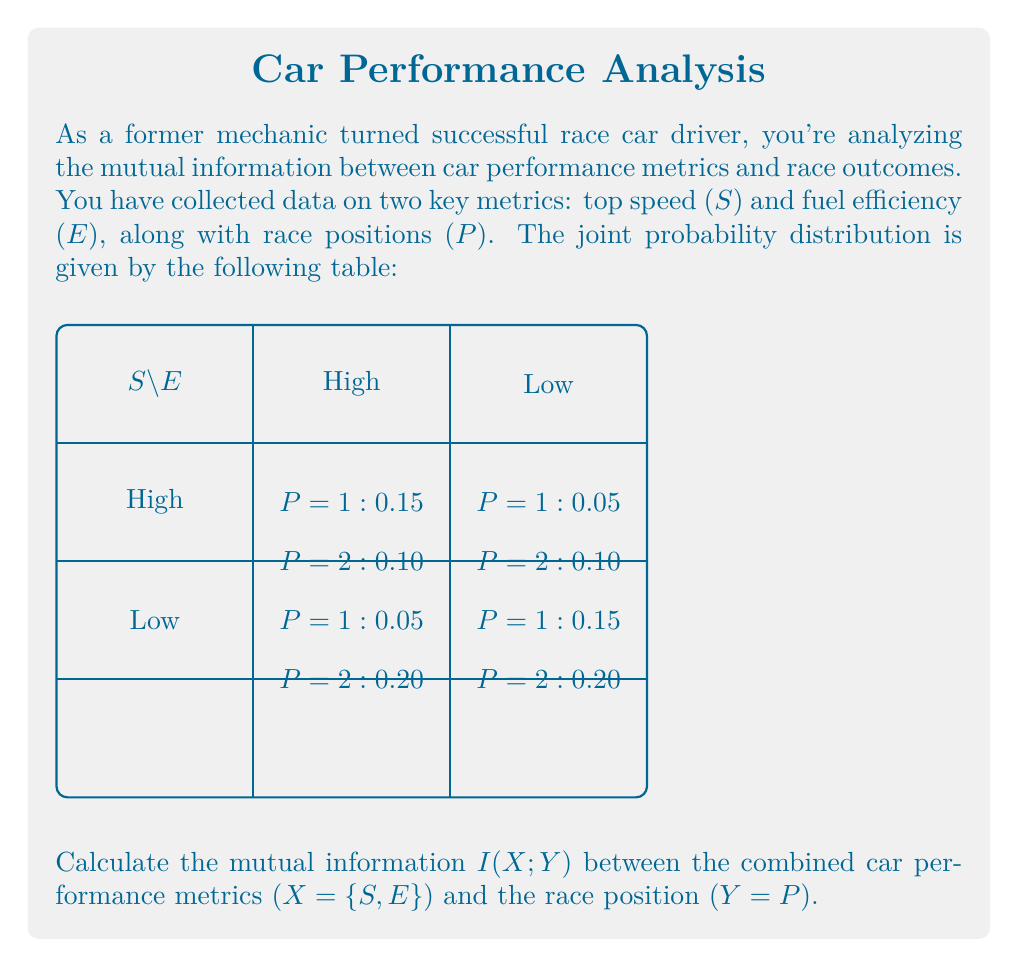Can you solve this math problem? To calculate the mutual information $I(X;Y)$, we'll follow these steps:

1) First, we need to calculate the marginal probabilities:

   $P(X = \{High, High\}) = 0.15 + 0.10 = 0.25$
   $P(X = \{High, Low\}) = 0.05 + 0.10 = 0.15$
   $P(X = \{Low, High\}) = 0.05 + 0.20 = 0.25$
   $P(X = \{Low, Low\}) = 0.15 + 0.20 = 0.35$

   $P(Y = 1) = 0.15 + 0.05 + 0.05 + 0.15 = 0.40$
   $P(Y = 2) = 0.10 + 0.10 + 0.20 + 0.20 = 0.60$

2) The mutual information is defined as:

   $I(X;Y) = \sum_{x,y} P(x,y) \log_2 \frac{P(x,y)}{P(x)P(y)}$

3) Let's calculate each term:

   $0.15 \log_2 \frac{0.15}{0.25 \cdot 0.40} = 0.15 \log_2 1.5 = 0.0874$
   $0.10 \log_2 \frac{0.10}{0.25 \cdot 0.60} = 0.10 \log_2 0.6667 = -0.0566$
   $0.05 \log_2 \frac{0.05}{0.15 \cdot 0.40} = 0.05 \log_2 0.8333 = -0.0139$
   $0.10 \log_2 \frac{0.10}{0.15 \cdot 0.60} = 0.10 \log_2 1.1111 = 0.0152$
   $0.05 \log_2 \frac{0.05}{0.25 \cdot 0.40} = 0.05 \log_2 0.5 = -0.0500$
   $0.20 \log_2 \frac{0.20}{0.25 \cdot 0.60} = 0.20 \log_2 1.3333 = 0.0874$
   $0.15 \log_2 \frac{0.15}{0.35 \cdot 0.40} = 0.15 \log_2 1.0714 = 0.0149$
   $0.20 \log_2 \frac{0.20}{0.35 \cdot 0.60} = 0.20 \log_2 0.9524 = -0.0141$

4) Sum all these terms:

   $I(X;Y) = 0.0874 - 0.0566 - 0.0139 + 0.0152 - 0.0500 + 0.0874 + 0.0149 - 0.0141 = 0.0703$

Therefore, the mutual information $I(X;Y)$ is approximately 0.0703 bits.
Answer: 0.0703 bits 